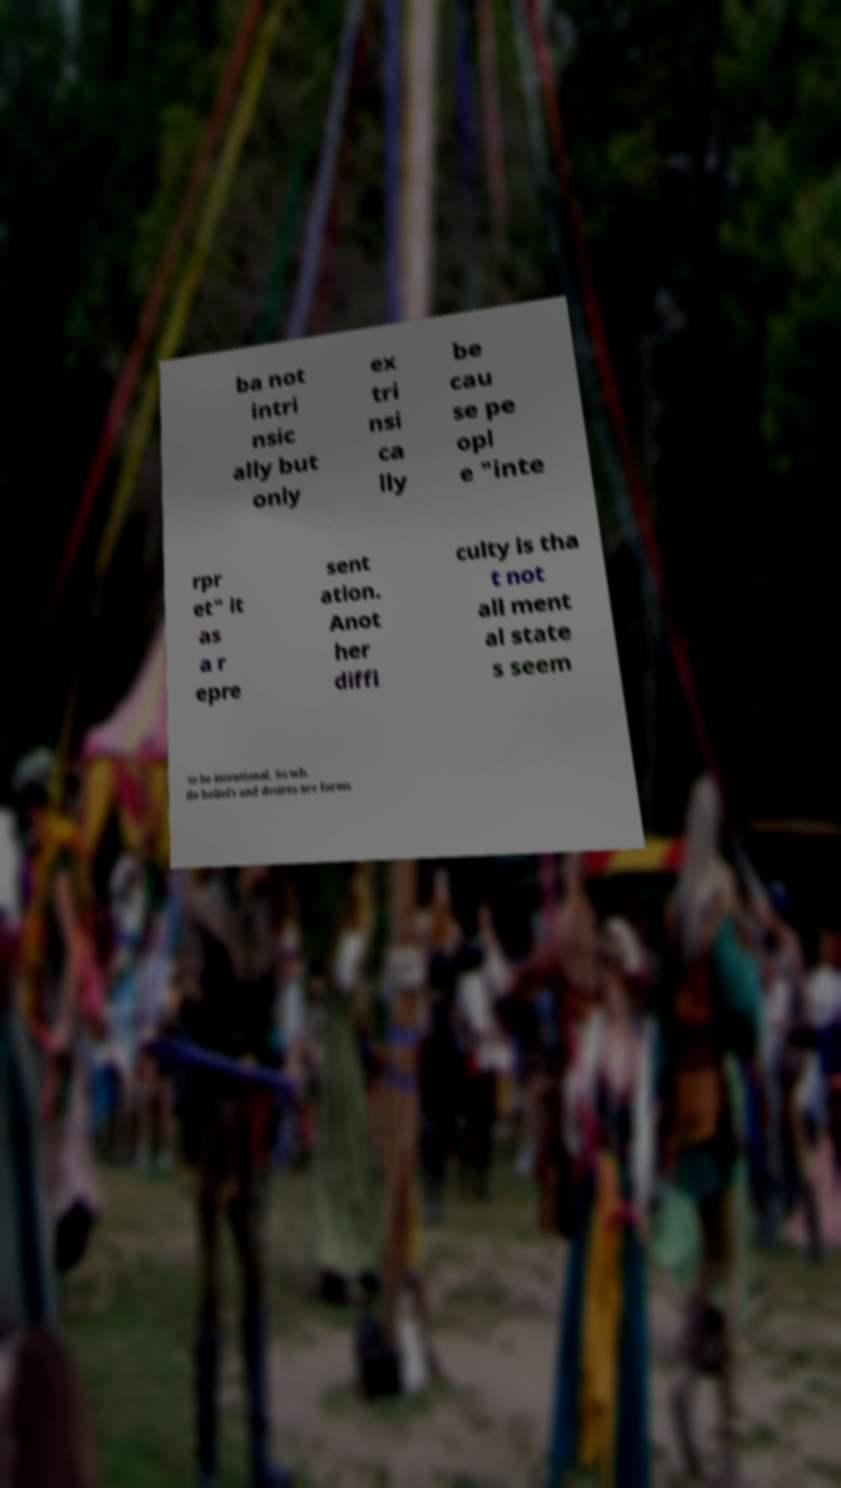Could you extract and type out the text from this image? ba not intri nsic ally but only ex tri nsi ca lly be cau se pe opl e "inte rpr et" it as a r epre sent ation. Anot her diffi culty is tha t not all ment al state s seem to be intentional. So wh ile beliefs and desires are forms 